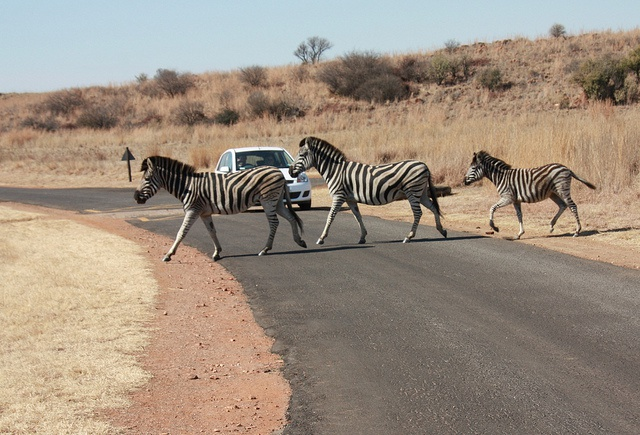Describe the objects in this image and their specific colors. I can see zebra in lightblue, black, gray, and darkgray tones, zebra in lightblue, black, gray, and darkgray tones, zebra in lightblue, black, gray, and darkgray tones, and car in lightblue, black, white, darkgray, and gray tones in this image. 